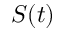Convert formula to latex. <formula><loc_0><loc_0><loc_500><loc_500>S ( t )</formula> 